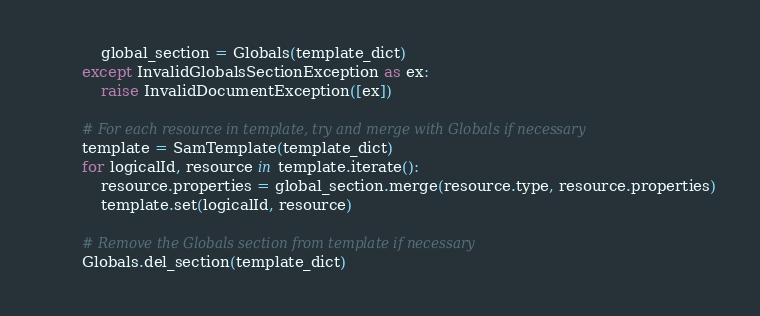<code> <loc_0><loc_0><loc_500><loc_500><_Python_>            global_section = Globals(template_dict)
        except InvalidGlobalsSectionException as ex:
            raise InvalidDocumentException([ex])

        # For each resource in template, try and merge with Globals if necessary
        template = SamTemplate(template_dict)
        for logicalId, resource in template.iterate():
            resource.properties = global_section.merge(resource.type, resource.properties)
            template.set(logicalId, resource)

        # Remove the Globals section from template if necessary
        Globals.del_section(template_dict)
</code> 